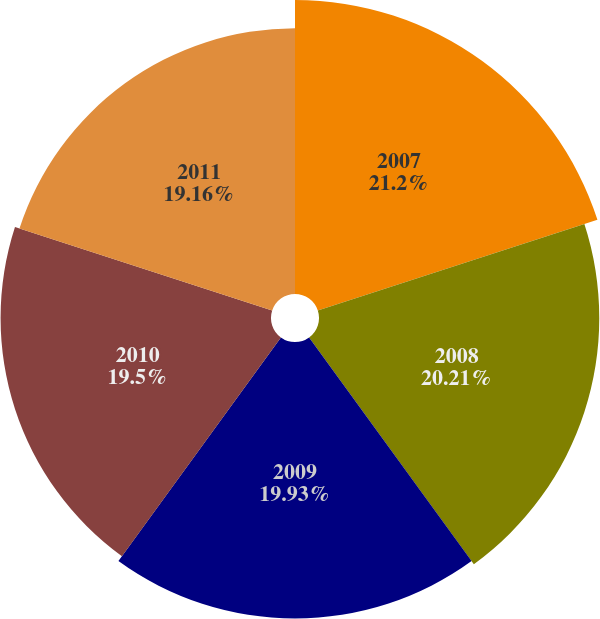Convert chart to OTSL. <chart><loc_0><loc_0><loc_500><loc_500><pie_chart><fcel>2007<fcel>2008<fcel>2009<fcel>2010<fcel>2011<nl><fcel>21.2%<fcel>20.21%<fcel>19.93%<fcel>19.5%<fcel>19.16%<nl></chart> 